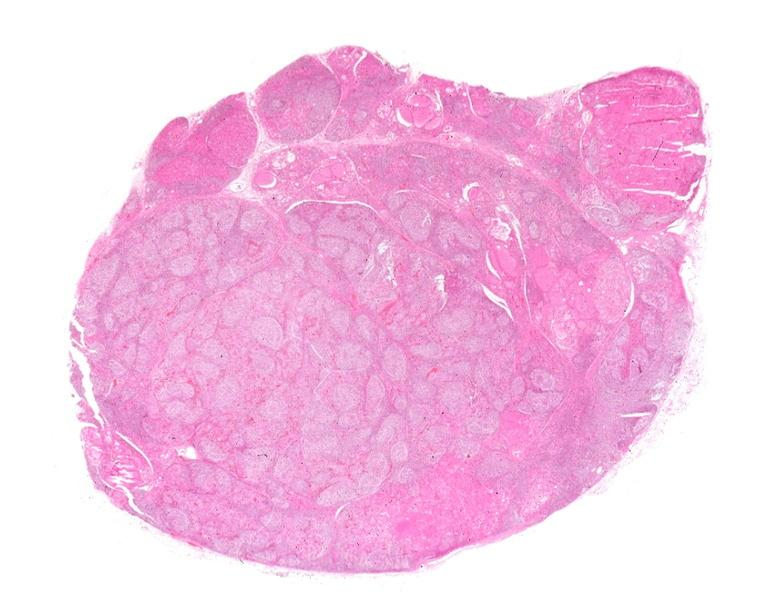what is present?
Answer the question using a single word or phrase. Endocrine 